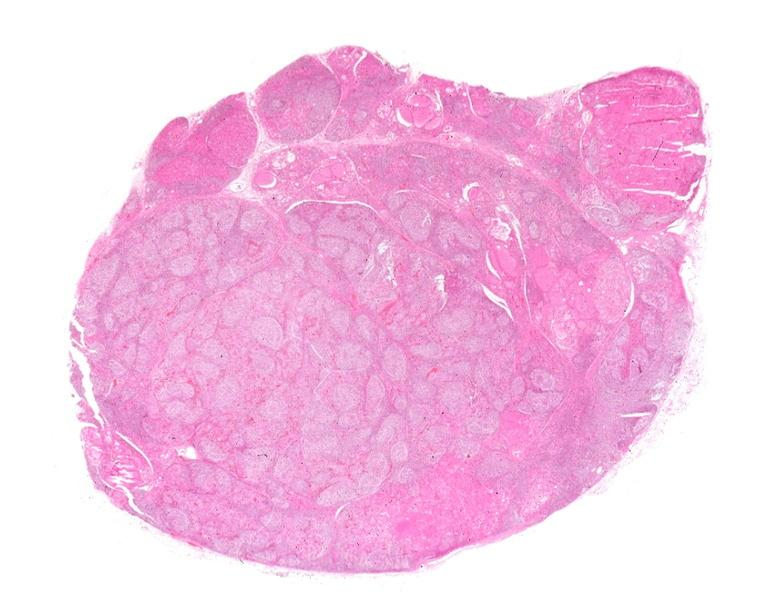what is present?
Answer the question using a single word or phrase. Endocrine 